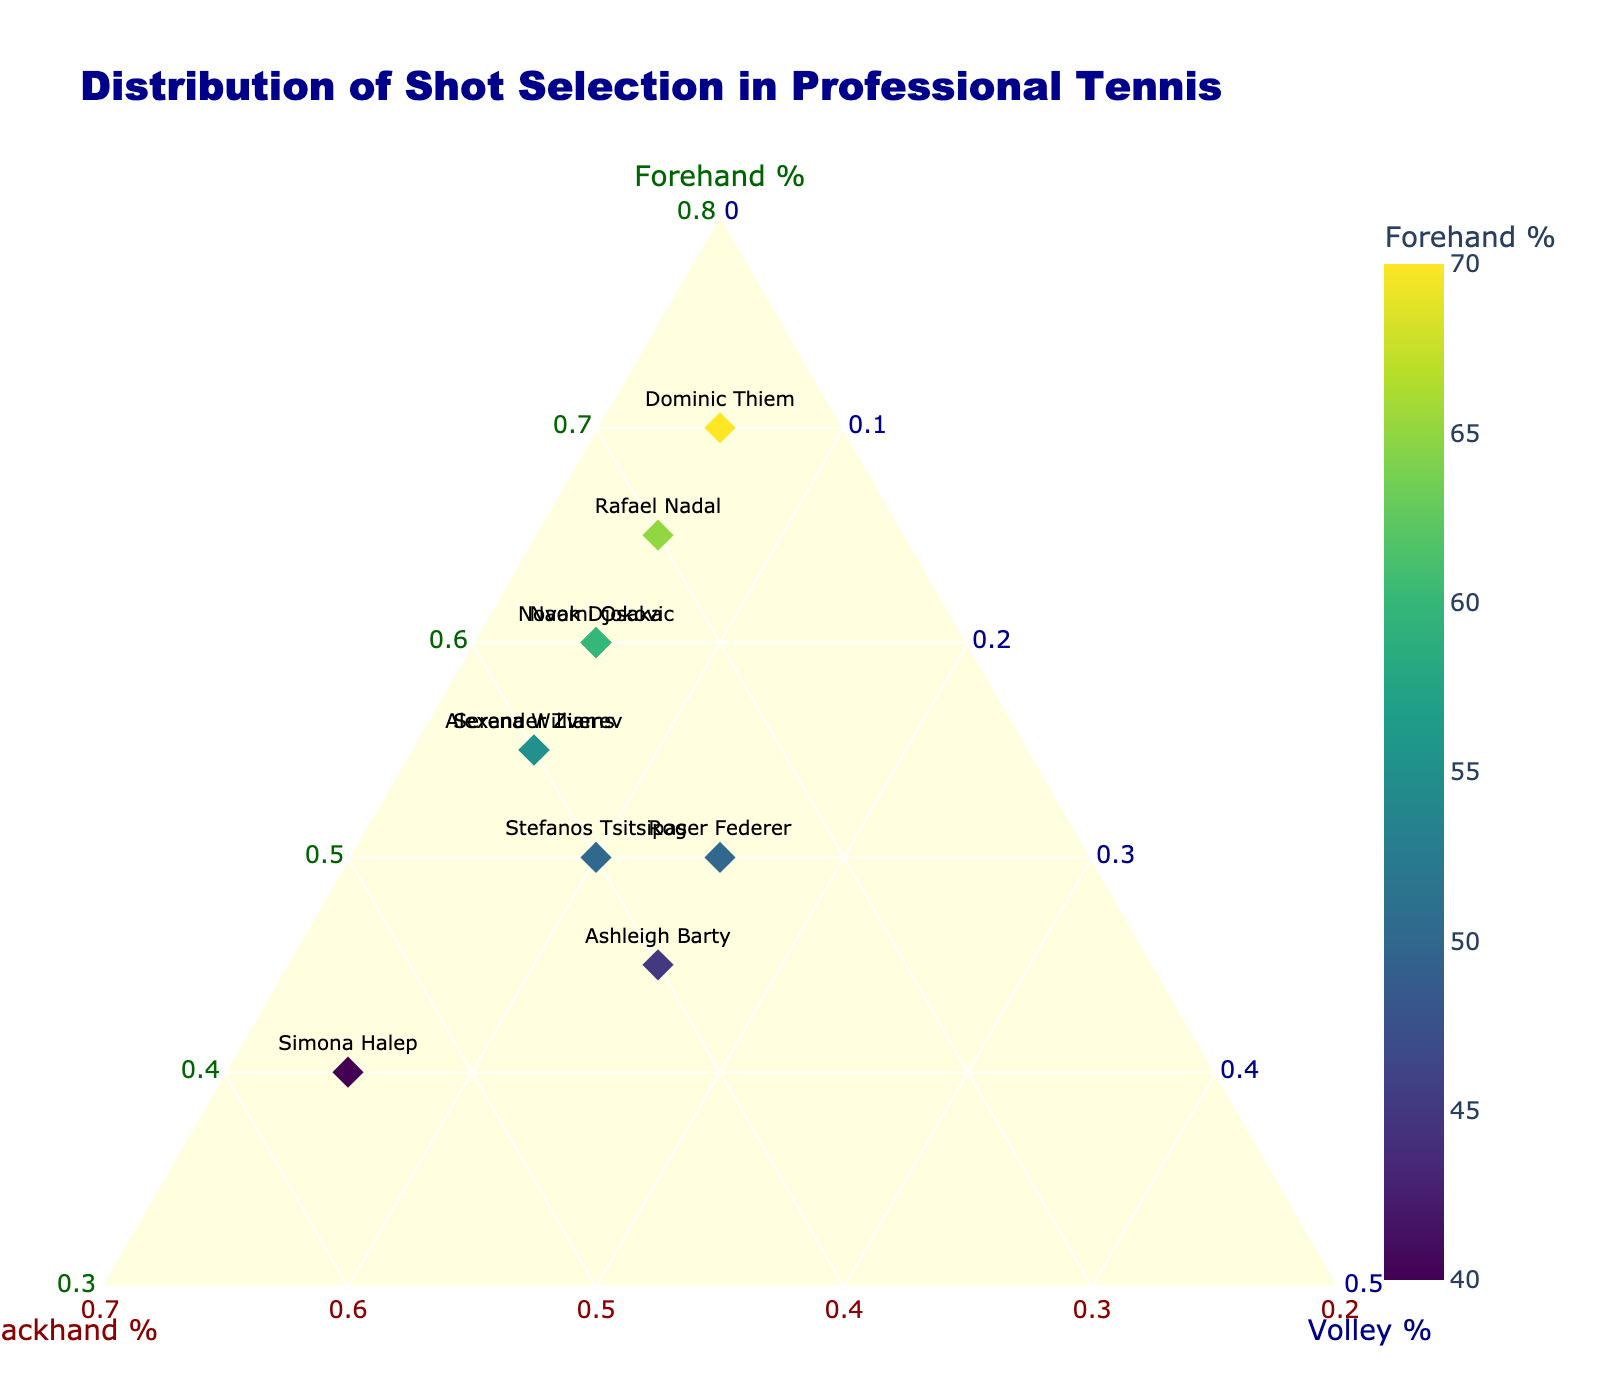What's the title of the figure? The title is located at the top of the figure, displaying the context and purpose of the plot. For this figure, the title is clearly written.
Answer: Distribution of Shot Selection in Professional Tennis What does the color of the markers represent? The color of the markers is determined by the proportion of Forehand shots, as indicated by the color bar on the right side of the plot titled 'Forehand %'.
Answer: Forehand percentage Which player has the highest proportion of Forehand shots? By looking at the data points and identifying the one with the highest Forehand percentage (indicated by color or value), we find the player with the highest proportion of Forehand shots. The player with the Forehand percentage around 70% stands out.
Answer: Dominic Thiem How many players are represented in the plot? Count the number of data points (markers) each representing a player. This corresponds to the total number of unique players in the dataset.
Answer: 10 Which player has the highest Backhand shot percentage? Locate the data point with the highest value along the Backhand axis. By comparing the Backhand percentages, the player with the highest value (around 55%) is identified.
Answer: Simona Halep Compare the Volley shot percentages between players with the same Forehand percentage. From the figure, identify players with similar Forehand percentages (e.g., around 50-55%). Then compare their Volley percentages by looking at their positions relative to the Volley axis.
Answer: Roger Federer and Stefanos Tsitsipas, Federer has 15% Volley while Tsitsipas has 10% Volley What are the minimum percentage values set for each axis? Look at the titles and scales on the axes, which indicate the data range and minimum values visually. The minimum values can be inferred from the start of each axis.
Answer: Forehand: 30%, Backhand: 20%, Volley: 0% Who has a higher Backhand percentage, Rafael Nadal or Naomi Osaka? Locate both players on the plot and compare their positions along the Backhand axis. One has a Backhand percentage around 30% and the other around 35%.
Answer: Naomi Osaka Identify the player with the most balanced distribution of shots. The most balanced distribution means close to equal percentages for Forehand, Backhand, and Volley. Look for the data point closest to the center of the plot, away from the corners.
Answer: Ashleigh Barty Among Roger Federer, Serena Williams, and Novak Djokovic, who has the highest Volley shot percentage? Identify these players and compare their positions along the Volley axis. One stands out with a higher Volley percentage (around 15%).
Answer: Roger Federer 